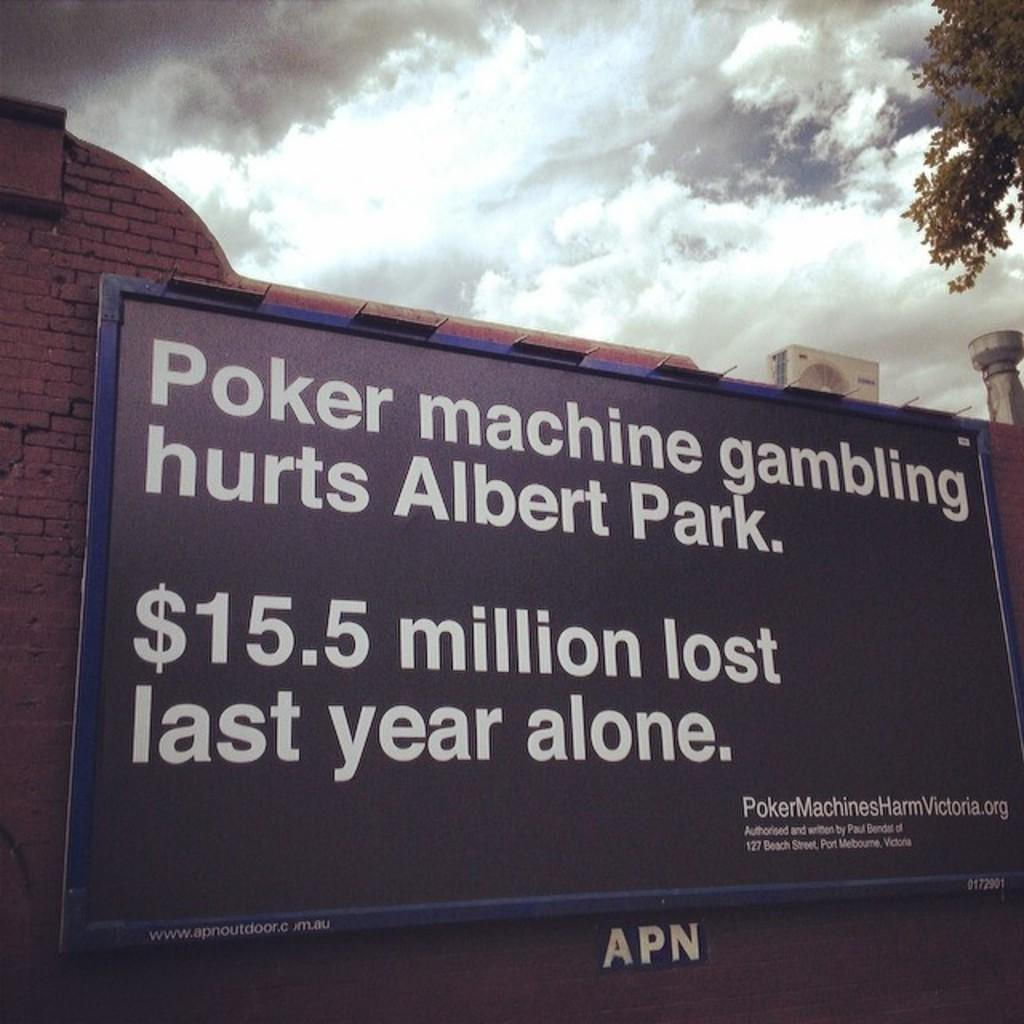<image>
Write a terse but informative summary of the picture. A black sign on a brick wall that state gambling hurts Albert Park. 